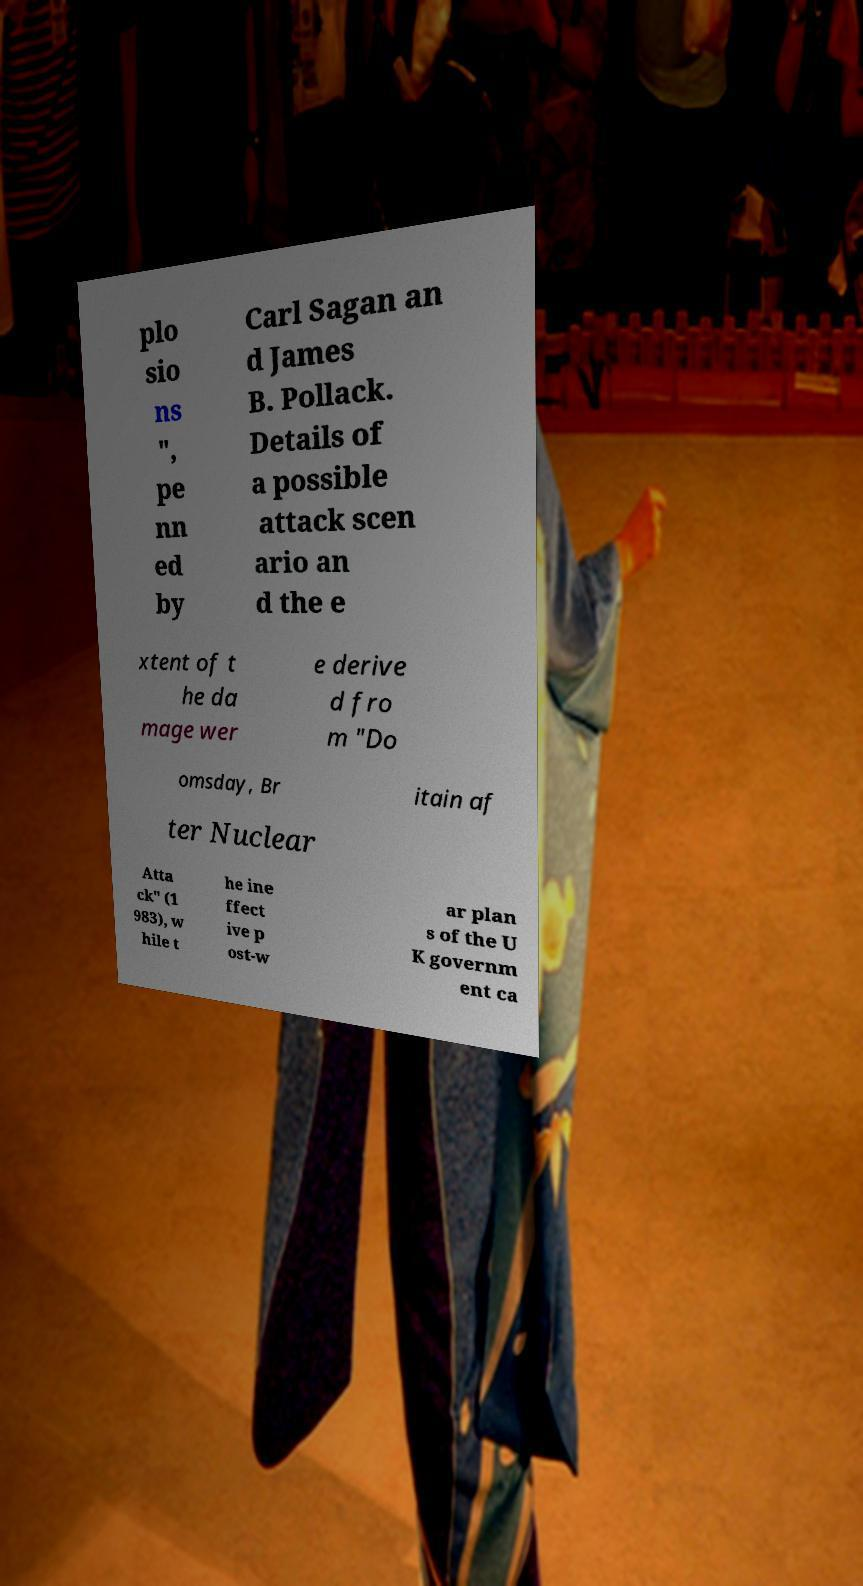There's text embedded in this image that I need extracted. Can you transcribe it verbatim? plo sio ns ", pe nn ed by Carl Sagan an d James B. Pollack. Details of a possible attack scen ario an d the e xtent of t he da mage wer e derive d fro m "Do omsday, Br itain af ter Nuclear Atta ck" (1 983), w hile t he ine ffect ive p ost-w ar plan s of the U K governm ent ca 